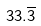Convert formula to latex. <formula><loc_0><loc_0><loc_500><loc_500>3 3 . \overline { 3 }</formula> 